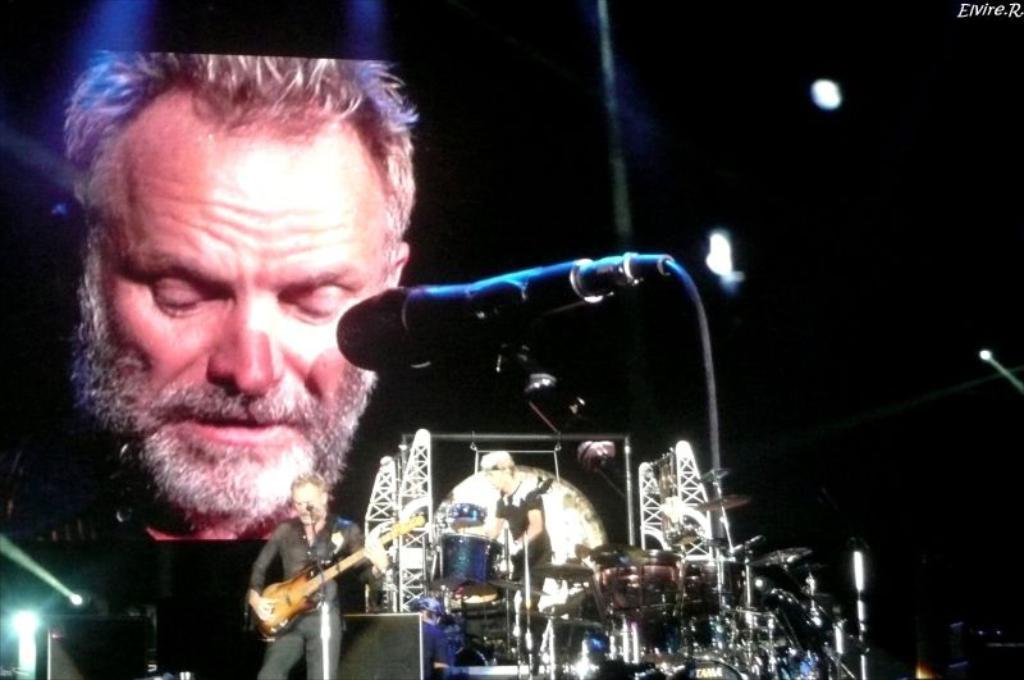Please provide a concise description of this image. In this image, there are two persons standing and wearing clothes. There is a person in the bottom left of the image playing a guitar. There is a person in the center of the image playing drums. There is screen behind these two persons. There are some musical instruments in the bottom right of the image. 